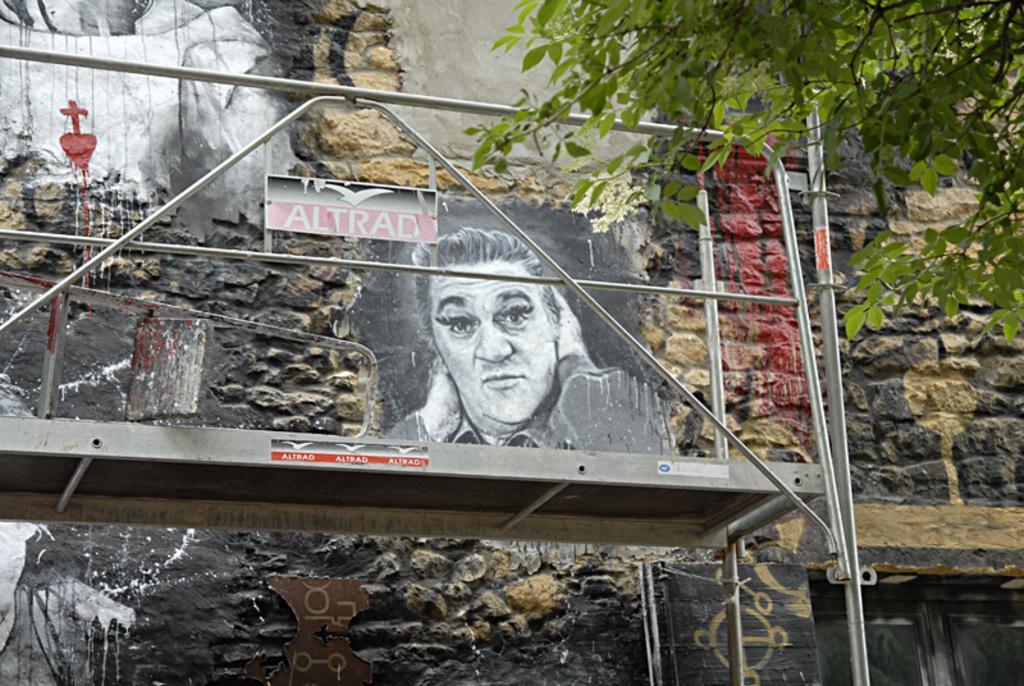Describe this image in one or two sentences. In this image we can see a building with a door and we can also see the painting on the building wall. We can see some metal rods and also a tree. 